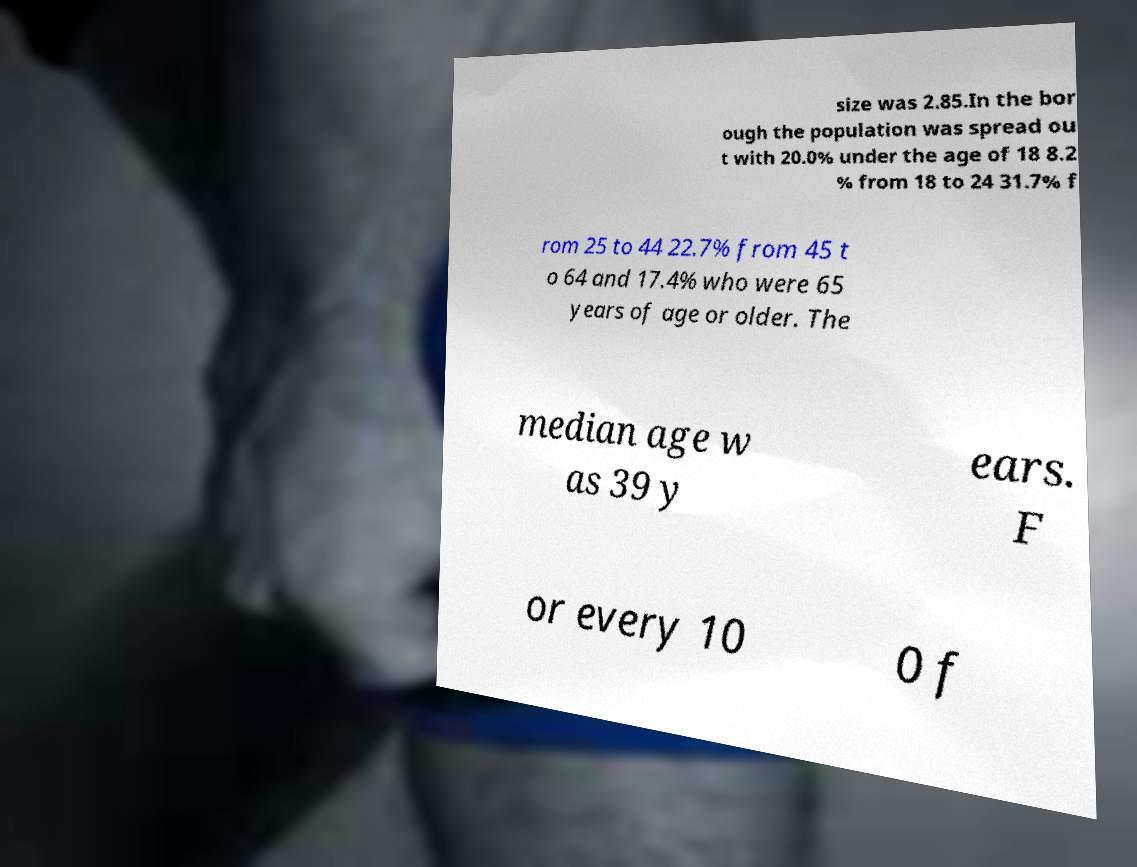For documentation purposes, I need the text within this image transcribed. Could you provide that? size was 2.85.In the bor ough the population was spread ou t with 20.0% under the age of 18 8.2 % from 18 to 24 31.7% f rom 25 to 44 22.7% from 45 t o 64 and 17.4% who were 65 years of age or older. The median age w as 39 y ears. F or every 10 0 f 